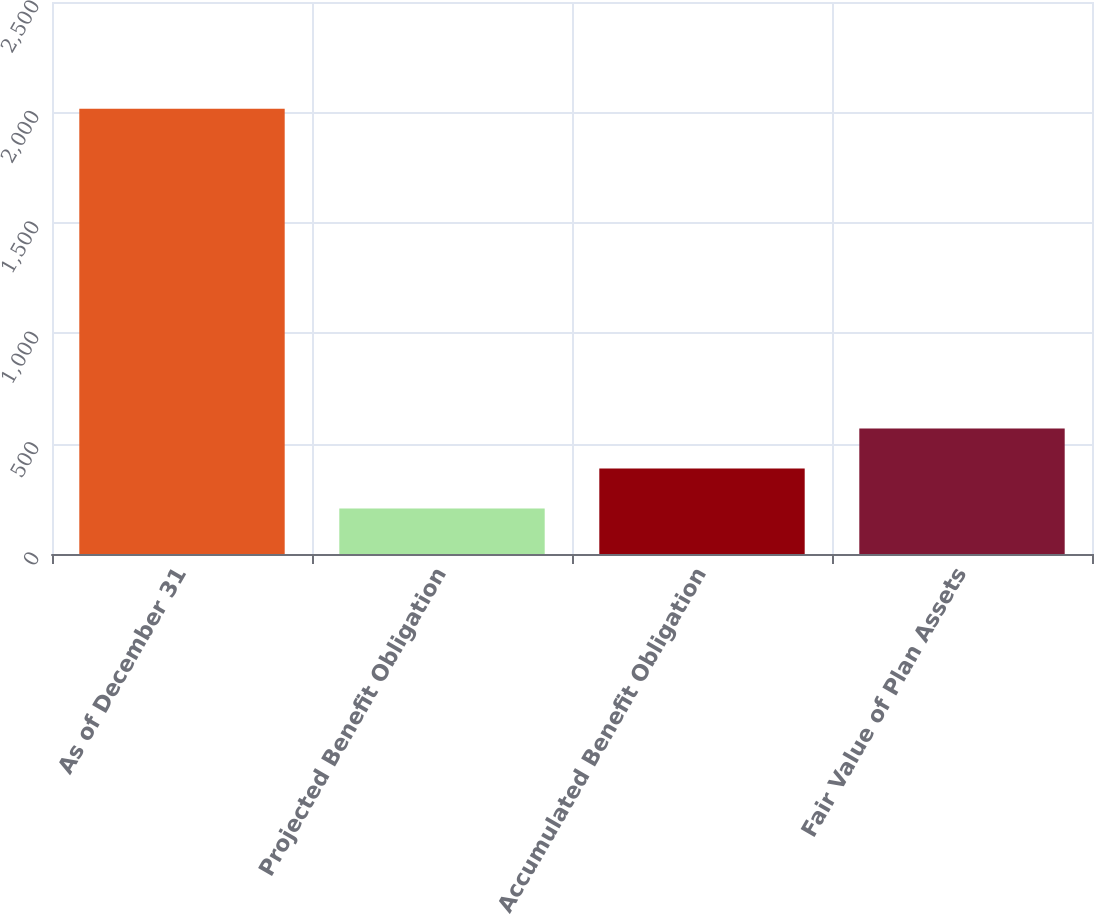Convert chart. <chart><loc_0><loc_0><loc_500><loc_500><bar_chart><fcel>As of December 31<fcel>Projected Benefit Obligation<fcel>Accumulated Benefit Obligation<fcel>Fair Value of Plan Assets<nl><fcel>2016<fcel>206<fcel>387<fcel>568<nl></chart> 